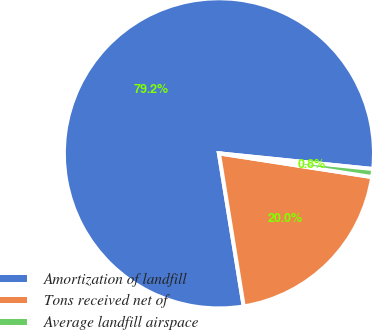Convert chart. <chart><loc_0><loc_0><loc_500><loc_500><pie_chart><fcel>Amortization of landfill<fcel>Tons received net of<fcel>Average landfill airspace<nl><fcel>79.17%<fcel>20.0%<fcel>0.83%<nl></chart> 